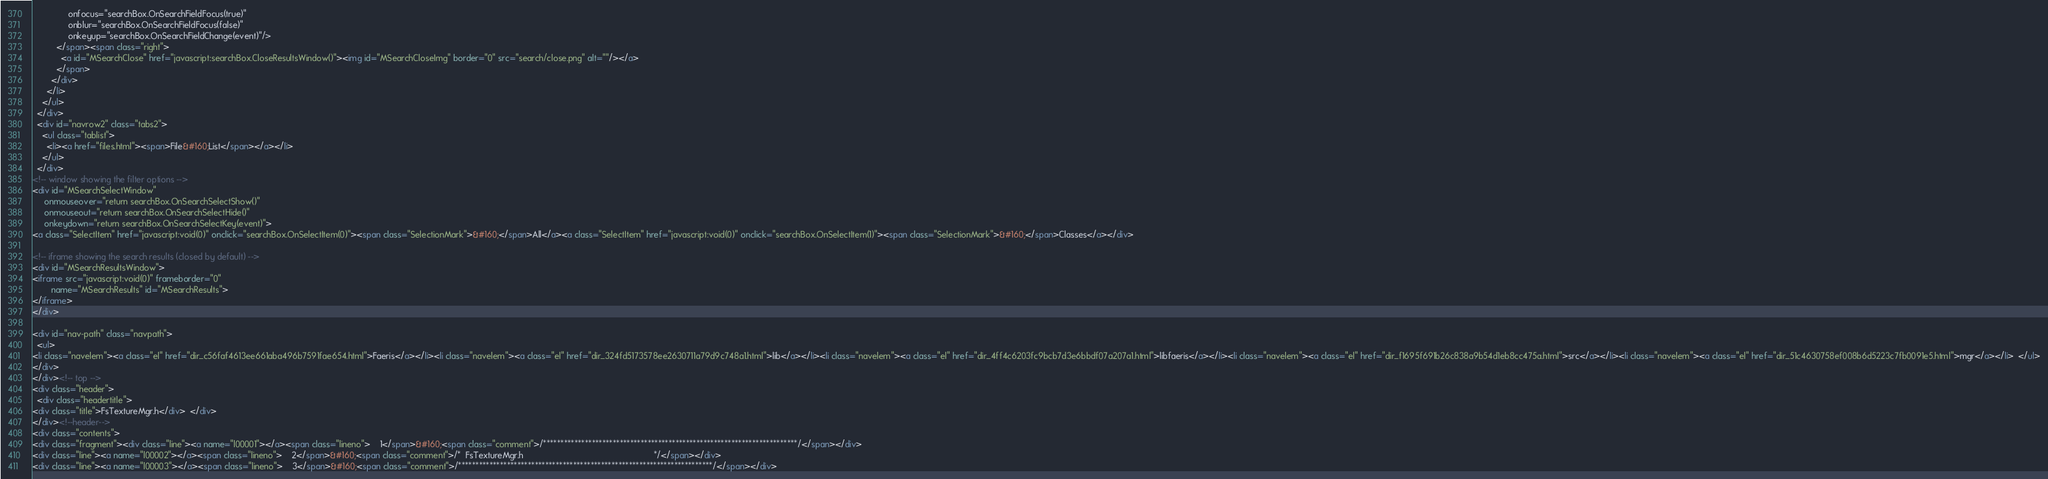Convert code to text. <code><loc_0><loc_0><loc_500><loc_500><_HTML_>               onfocus="searchBox.OnSearchFieldFocus(true)" 
               onblur="searchBox.OnSearchFieldFocus(false)" 
               onkeyup="searchBox.OnSearchFieldChange(event)"/>
          </span><span class="right">
            <a id="MSearchClose" href="javascript:searchBox.CloseResultsWindow()"><img id="MSearchCloseImg" border="0" src="search/close.png" alt=""/></a>
          </span>
        </div>
      </li>
    </ul>
  </div>
  <div id="navrow2" class="tabs2">
    <ul class="tablist">
      <li><a href="files.html"><span>File&#160;List</span></a></li>
    </ul>
  </div>
<!-- window showing the filter options -->
<div id="MSearchSelectWindow"
     onmouseover="return searchBox.OnSearchSelectShow()"
     onmouseout="return searchBox.OnSearchSelectHide()"
     onkeydown="return searchBox.OnSearchSelectKey(event)">
<a class="SelectItem" href="javascript:void(0)" onclick="searchBox.OnSelectItem(0)"><span class="SelectionMark">&#160;</span>All</a><a class="SelectItem" href="javascript:void(0)" onclick="searchBox.OnSelectItem(1)"><span class="SelectionMark">&#160;</span>Classes</a></div>

<!-- iframe showing the search results (closed by default) -->
<div id="MSearchResultsWindow">
<iframe src="javascript:void(0)" frameborder="0" 
        name="MSearchResults" id="MSearchResults">
</iframe>
</div>

<div id="nav-path" class="navpath">
  <ul>
<li class="navelem"><a class="el" href="dir_c56faf4613ee661aba496b7591fae654.html">Faeris</a></li><li class="navelem"><a class="el" href="dir_324fd5173578ee2630711a79d9c748a1.html">lib</a></li><li class="navelem"><a class="el" href="dir_4ff4c6203fc9bcb7d3e6bbdf07a207a1.html">libfaeris</a></li><li class="navelem"><a class="el" href="dir_f1695f691b26c838a9b54d1eb8cc475a.html">src</a></li><li class="navelem"><a class="el" href="dir_51c4630758ef008b6d5223c7fb0091e5.html">mgr</a></li>  </ul>
</div>
</div><!-- top -->
<div class="header">
  <div class="headertitle">
<div class="title">FsTextureMgr.h</div>  </div>
</div><!--header-->
<div class="contents">
<div class="fragment"><div class="line"><a name="l00001"></a><span class="lineno">    1</span>&#160;<span class="comment">/*************************************************************************/</span></div>
<div class="line"><a name="l00002"></a><span class="lineno">    2</span>&#160;<span class="comment">/*  FsTextureMgr.h                                                       */</span></div>
<div class="line"><a name="l00003"></a><span class="lineno">    3</span>&#160;<span class="comment">/*************************************************************************/</span></div></code> 